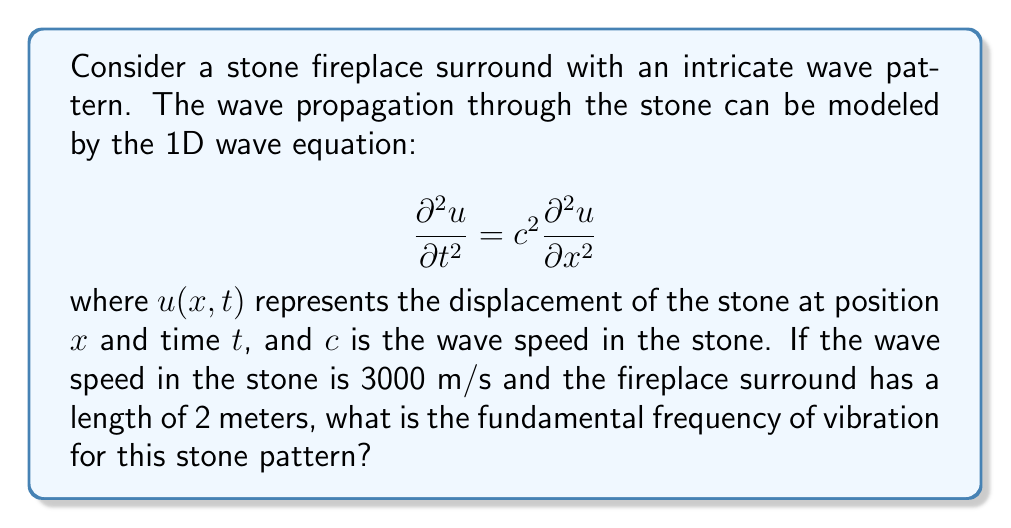Show me your answer to this math problem. To solve this problem, we'll follow these steps:

1) The fundamental frequency of vibration corresponds to the lowest eigenfrequency of the wave equation with fixed boundary conditions (assuming the ends of the fireplace surround are fixed).

2) For a string (or in this case, a stone pattern) of length $L$ with fixed ends, the eigenfrequencies are given by:

   $$f_n = \frac{nc}{2L}$$

   where $n = 1, 2, 3, ...$ and $c$ is the wave speed.

3) The fundamental frequency is the lowest frequency, which occurs when $n = 1$. So we use:

   $$f_1 = \frac{c}{2L}$$

4) We are given:
   - Wave speed: $c = 3000$ m/s
   - Length of the fireplace surround: $L = 2$ m

5) Substituting these values into the equation:

   $$f_1 = \frac{3000}{2(2)} = \frac{3000}{4} = 750$$

Therefore, the fundamental frequency of vibration for this stone pattern is 750 Hz.
Answer: 750 Hz 